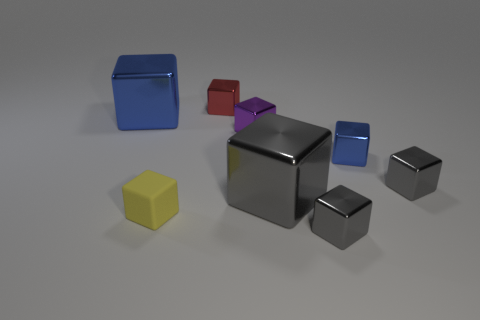Subtract all yellow balls. How many gray blocks are left? 3 Subtract all gray blocks. How many blocks are left? 5 Subtract all tiny yellow rubber cubes. How many cubes are left? 7 Add 2 purple things. How many objects exist? 10 Subtract all yellow cubes. Subtract all red spheres. How many cubes are left? 7 Add 3 purple cylinders. How many purple cylinders exist? 3 Subtract 1 red blocks. How many objects are left? 7 Subtract all purple objects. Subtract all tiny blue balls. How many objects are left? 7 Add 6 gray metallic objects. How many gray metallic objects are left? 9 